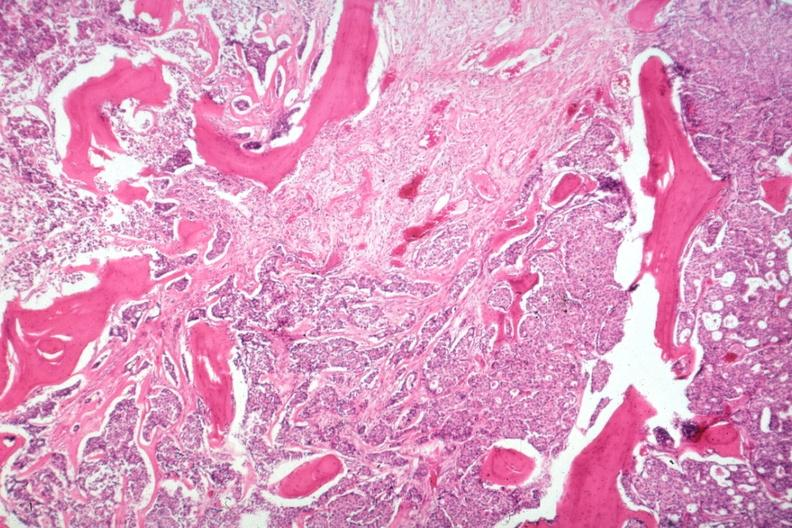what is islands of tumor?
Answer the question using a single word or phrase. Gross 